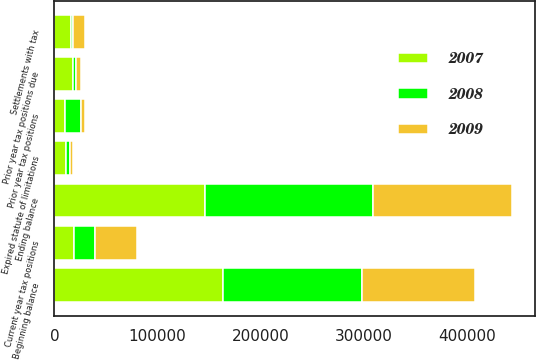Convert chart. <chart><loc_0><loc_0><loc_500><loc_500><stacked_bar_chart><ecel><fcel>Beginning balance<fcel>Current year tax positions<fcel>Prior year tax positions<fcel>Prior year tax positions due<fcel>Settlements with tax<fcel>Expired statute of limitations<fcel>Ending balance<nl><fcel>2007<fcel>163185<fcel>19064<fcel>9914<fcel>18248<fcel>16460<fcel>11708<fcel>145747<nl><fcel>2008<fcel>134826<fcel>20447<fcel>15654<fcel>2613<fcel>1397<fcel>3732<fcel>163185<nl><fcel>2009<fcel>109476<fcel>40288<fcel>4544<fcel>4886<fcel>11990<fcel>2606<fcel>134826<nl></chart> 